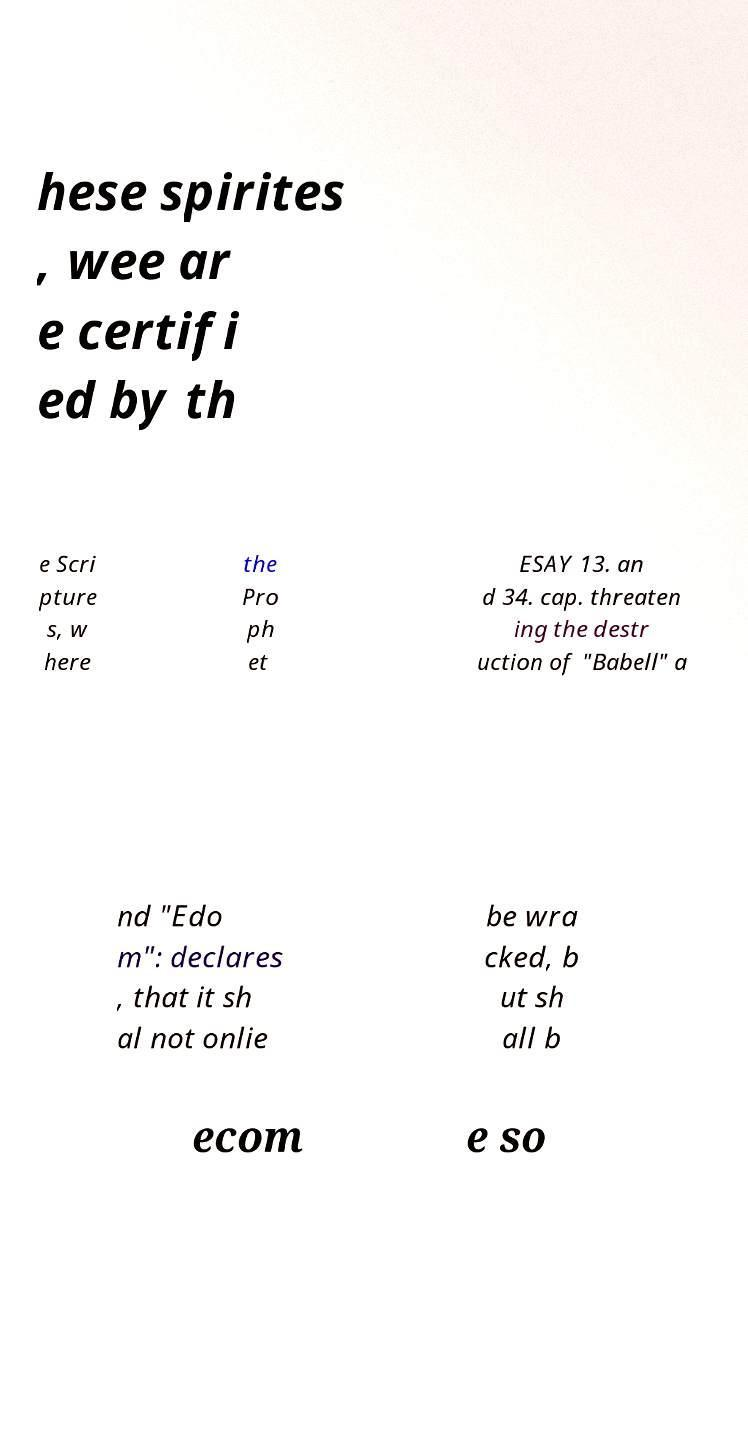Can you read and provide the text displayed in the image?This photo seems to have some interesting text. Can you extract and type it out for me? hese spirites , wee ar e certifi ed by th e Scri pture s, w here the Pro ph et ESAY 13. an d 34. cap. threaten ing the destr uction of "Babell" a nd "Edo m": declares , that it sh al not onlie be wra cked, b ut sh all b ecom e so 